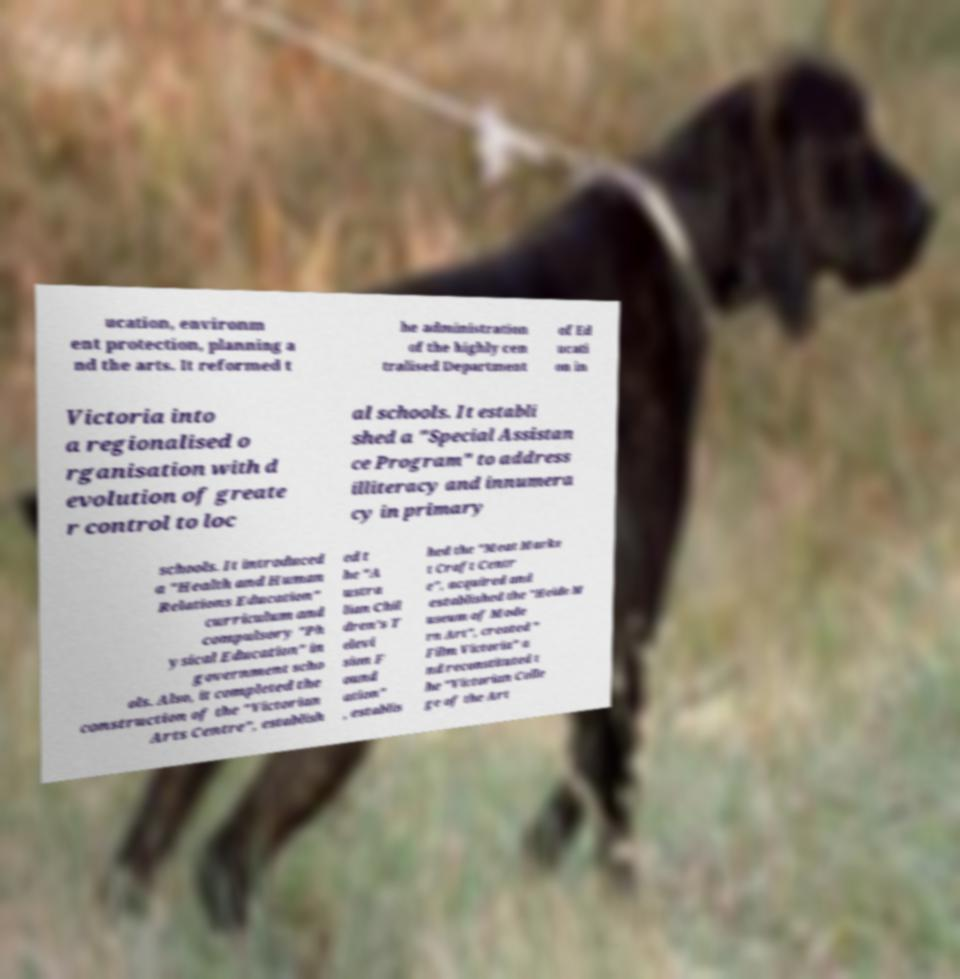Please read and relay the text visible in this image. What does it say? ucation, environm ent protection, planning a nd the arts. It reformed t he administration of the highly cen tralised Department of Ed ucati on in Victoria into a regionalised o rganisation with d evolution of greate r control to loc al schools. It establi shed a "Special Assistan ce Program" to address illiteracy and innumera cy in primary schools. It introduced a "Health and Human Relations Education" curriculum and compulsory "Ph ysical Education" in government scho ols. Also, it completed the construction of the "Victorian Arts Centre", establish ed t he "A ustra lian Chil dren's T elevi sion F ound ation" , establis hed the "Meat Marke t Craft Centr e", acquired and established the "Heide M useum of Mode rn Art", created " Film Victoria" a nd reconstituted t he "Victorian Colle ge of the Art 